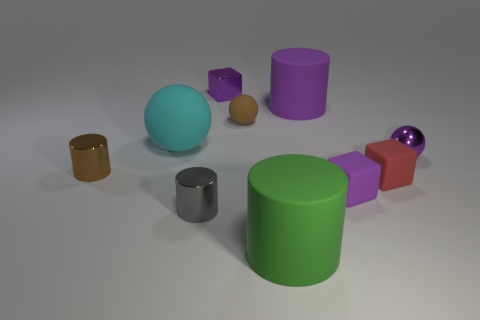Subtract all blocks. How many objects are left? 7 Add 1 purple objects. How many purple objects are left? 5 Add 6 large brown blocks. How many large brown blocks exist? 6 Subtract 0 blue cylinders. How many objects are left? 10 Subtract all small red objects. Subtract all large cyan rubber balls. How many objects are left? 8 